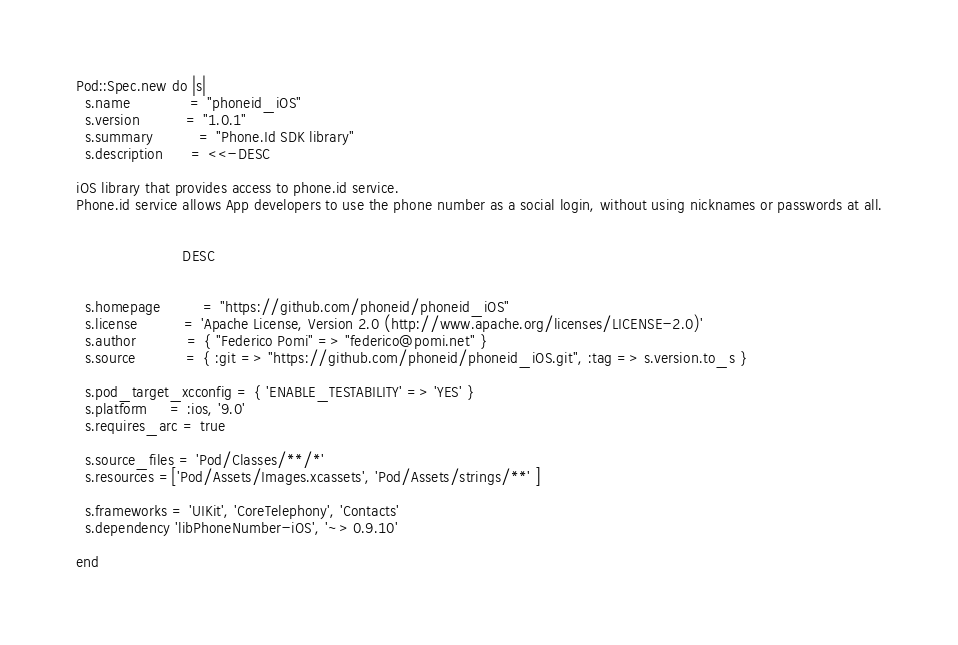<code> <loc_0><loc_0><loc_500><loc_500><_Ruby_>
Pod::Spec.new do |s|
  s.name             = "phoneid_iOS"
  s.version          = "1.0.1"
  s.summary          = "Phone.Id SDK library"
  s.description      = <<-DESC

iOS library that provides access to phone.id service.
Phone.id service allows App developers to use the phone number as a social login, without using nicknames or passwords at all.


                       DESC


  s.homepage         = "https://github.com/phoneid/phoneid_iOS"
  s.license          = 'Apache License, Version 2.0 (http://www.apache.org/licenses/LICENSE-2.0)'
  s.author           = { "Federico Pomi" => "federico@pomi.net" }
  s.source           = { :git => "https://github.com/phoneid/phoneid_iOS.git", :tag => s.version.to_s }

  s.pod_target_xcconfig = { 'ENABLE_TESTABILITY' => 'YES' }
  s.platform     = :ios, '9.0'
  s.requires_arc = true

  s.source_files = 'Pod/Classes/**/*'
  s.resources =['Pod/Assets/Images.xcassets', 'Pod/Assets/strings/**' ]

  s.frameworks = 'UIKit', 'CoreTelephony', 'Contacts'
  s.dependency 'libPhoneNumber-iOS', '~> 0.9.10'

end
</code> 